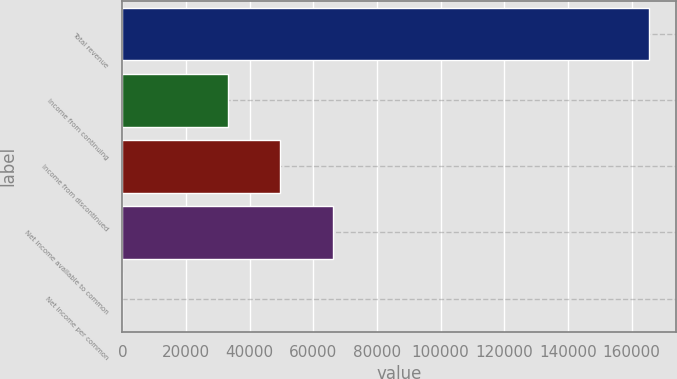Convert chart to OTSL. <chart><loc_0><loc_0><loc_500><loc_500><bar_chart><fcel>Total revenue<fcel>Income from continuing<fcel>Income from discontinued<fcel>Net income available to common<fcel>Net income per common<nl><fcel>165586<fcel>33117.8<fcel>49676.3<fcel>66234.9<fcel>0.74<nl></chart> 